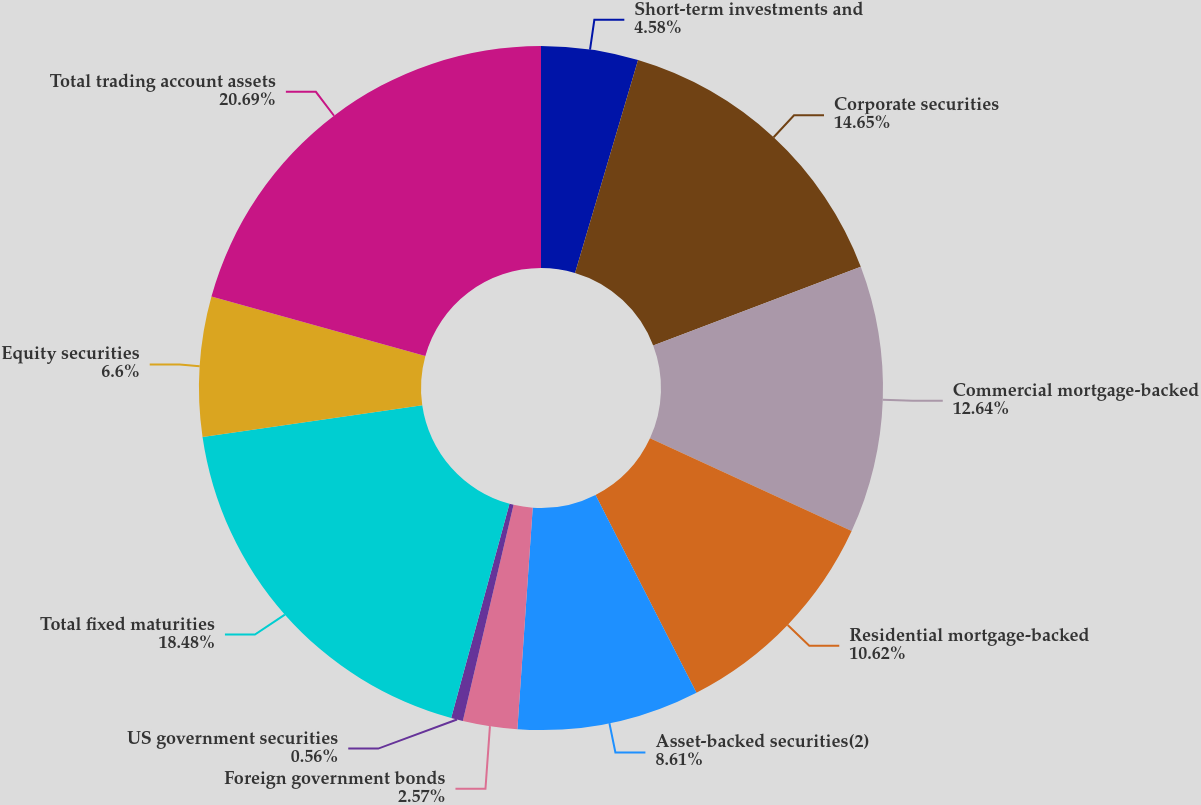Convert chart. <chart><loc_0><loc_0><loc_500><loc_500><pie_chart><fcel>Short-term investments and<fcel>Corporate securities<fcel>Commercial mortgage-backed<fcel>Residential mortgage-backed<fcel>Asset-backed securities(2)<fcel>Foreign government bonds<fcel>US government securities<fcel>Total fixed maturities<fcel>Equity securities<fcel>Total trading account assets<nl><fcel>4.58%<fcel>14.65%<fcel>12.64%<fcel>10.62%<fcel>8.61%<fcel>2.57%<fcel>0.56%<fcel>18.48%<fcel>6.6%<fcel>20.69%<nl></chart> 